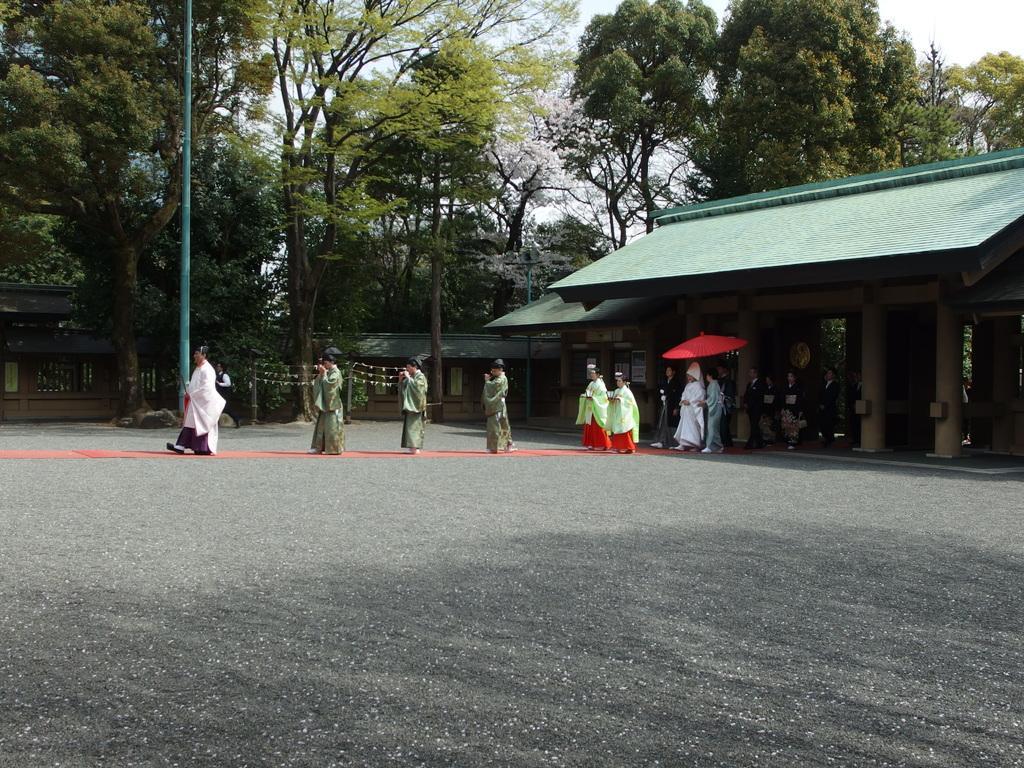Please provide a concise description of this image. In this picture I can see there are few people walking on the red color mat and the person is wearing a white color dress and holding a red color umbrella and in the backdrop there is a building and there are trees and a pole and the sky is clear. 